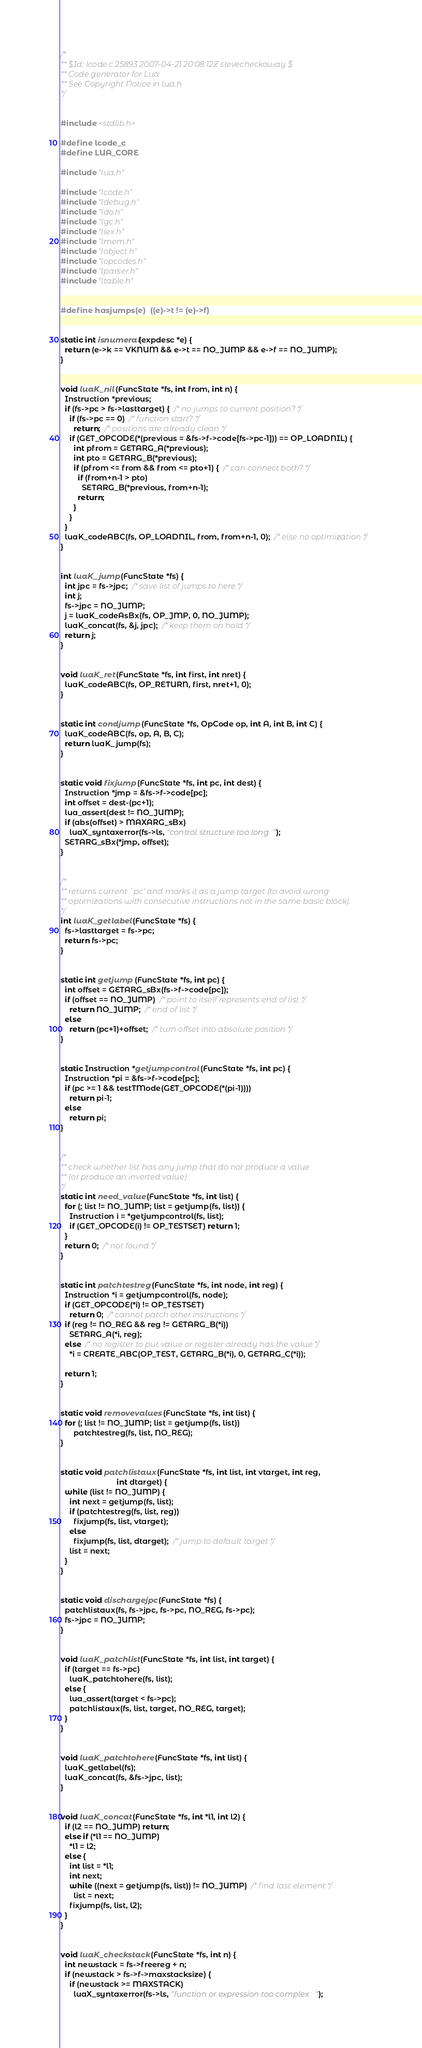<code> <loc_0><loc_0><loc_500><loc_500><_C_>/*
** $Id: lcode.c 25893 2007-04-21 20:08:12Z stevecheckoway $
** Code generator for Lua
** See Copyright Notice in lua.h
*/


#include <stdlib.h>

#define lcode_c
#define LUA_CORE

#include "lua.h"

#include "lcode.h"
#include "ldebug.h"
#include "ldo.h"
#include "lgc.h"
#include "llex.h"
#include "lmem.h"
#include "lobject.h"
#include "lopcodes.h"
#include "lparser.h"
#include "ltable.h"


#define hasjumps(e)	((e)->t != (e)->f)


static int isnumeral(expdesc *e) {
  return (e->k == VKNUM && e->t == NO_JUMP && e->f == NO_JUMP);
}


void luaK_nil (FuncState *fs, int from, int n) {
  Instruction *previous;
  if (fs->pc > fs->lasttarget) {  /* no jumps to current position? */
    if (fs->pc == 0)  /* function start? */
      return;  /* positions are already clean */
    if (GET_OPCODE(*(previous = &fs->f->code[fs->pc-1])) == OP_LOADNIL) {
      int pfrom = GETARG_A(*previous);
      int pto = GETARG_B(*previous);
      if (pfrom <= from && from <= pto+1) {  /* can connect both? */
        if (from+n-1 > pto)
          SETARG_B(*previous, from+n-1);
        return;
      }
    }
  }
  luaK_codeABC(fs, OP_LOADNIL, from, from+n-1, 0);  /* else no optimization */
}


int luaK_jump (FuncState *fs) {
  int jpc = fs->jpc;  /* save list of jumps to here */
  int j;
  fs->jpc = NO_JUMP;
  j = luaK_codeAsBx(fs, OP_JMP, 0, NO_JUMP);
  luaK_concat(fs, &j, jpc);  /* keep them on hold */
  return j;
}


void luaK_ret (FuncState *fs, int first, int nret) {
  luaK_codeABC(fs, OP_RETURN, first, nret+1, 0);
}


static int condjump (FuncState *fs, OpCode op, int A, int B, int C) {
  luaK_codeABC(fs, op, A, B, C);
  return luaK_jump(fs);
}


static void fixjump (FuncState *fs, int pc, int dest) {
  Instruction *jmp = &fs->f->code[pc];
  int offset = dest-(pc+1);
  lua_assert(dest != NO_JUMP);
  if (abs(offset) > MAXARG_sBx)
    luaX_syntaxerror(fs->ls, "control structure too long");
  SETARG_sBx(*jmp, offset);
}


/*
** returns current `pc' and marks it as a jump target (to avoid wrong
** optimizations with consecutive instructions not in the same basic block).
*/
int luaK_getlabel (FuncState *fs) {
  fs->lasttarget = fs->pc;
  return fs->pc;
}


static int getjump (FuncState *fs, int pc) {
  int offset = GETARG_sBx(fs->f->code[pc]);
  if (offset == NO_JUMP)  /* point to itself represents end of list */
    return NO_JUMP;  /* end of list */
  else
    return (pc+1)+offset;  /* turn offset into absolute position */
}


static Instruction *getjumpcontrol (FuncState *fs, int pc) {
  Instruction *pi = &fs->f->code[pc];
  if (pc >= 1 && testTMode(GET_OPCODE(*(pi-1))))
    return pi-1;
  else
    return pi;
}


/*
** check whether list has any jump that do not produce a value
** (or produce an inverted value)
*/
static int need_value (FuncState *fs, int list) {
  for (; list != NO_JUMP; list = getjump(fs, list)) {
    Instruction i = *getjumpcontrol(fs, list);
    if (GET_OPCODE(i) != OP_TESTSET) return 1;
  }
  return 0;  /* not found */
}


static int patchtestreg (FuncState *fs, int node, int reg) {
  Instruction *i = getjumpcontrol(fs, node);
  if (GET_OPCODE(*i) != OP_TESTSET)
    return 0;  /* cannot patch other instructions */
  if (reg != NO_REG && reg != GETARG_B(*i))
    SETARG_A(*i, reg);
  else  /* no register to put value or register already has the value */
    *i = CREATE_ABC(OP_TEST, GETARG_B(*i), 0, GETARG_C(*i));

  return 1;
}


static void removevalues (FuncState *fs, int list) {
  for (; list != NO_JUMP; list = getjump(fs, list))
      patchtestreg(fs, list, NO_REG);
}


static void patchlistaux (FuncState *fs, int list, int vtarget, int reg,
                          int dtarget) {
  while (list != NO_JUMP) {
    int next = getjump(fs, list);
    if (patchtestreg(fs, list, reg))
      fixjump(fs, list, vtarget);
    else
      fixjump(fs, list, dtarget);  /* jump to default target */
    list = next;
  }
}


static void dischargejpc (FuncState *fs) {
  patchlistaux(fs, fs->jpc, fs->pc, NO_REG, fs->pc);
  fs->jpc = NO_JUMP;
}


void luaK_patchlist (FuncState *fs, int list, int target) {
  if (target == fs->pc)
    luaK_patchtohere(fs, list);
  else {
    lua_assert(target < fs->pc);
    patchlistaux(fs, list, target, NO_REG, target);
  }
}


void luaK_patchtohere (FuncState *fs, int list) {
  luaK_getlabel(fs);
  luaK_concat(fs, &fs->jpc, list);
}


void luaK_concat (FuncState *fs, int *l1, int l2) {
  if (l2 == NO_JUMP) return;
  else if (*l1 == NO_JUMP)
    *l1 = l2;
  else {
    int list = *l1;
    int next;
    while ((next = getjump(fs, list)) != NO_JUMP)  /* find last element */
      list = next;
    fixjump(fs, list, l2);
  }
}


void luaK_checkstack (FuncState *fs, int n) {
  int newstack = fs->freereg + n;
  if (newstack > fs->f->maxstacksize) {
    if (newstack >= MAXSTACK)
      luaX_syntaxerror(fs->ls, "function or expression too complex");</code> 